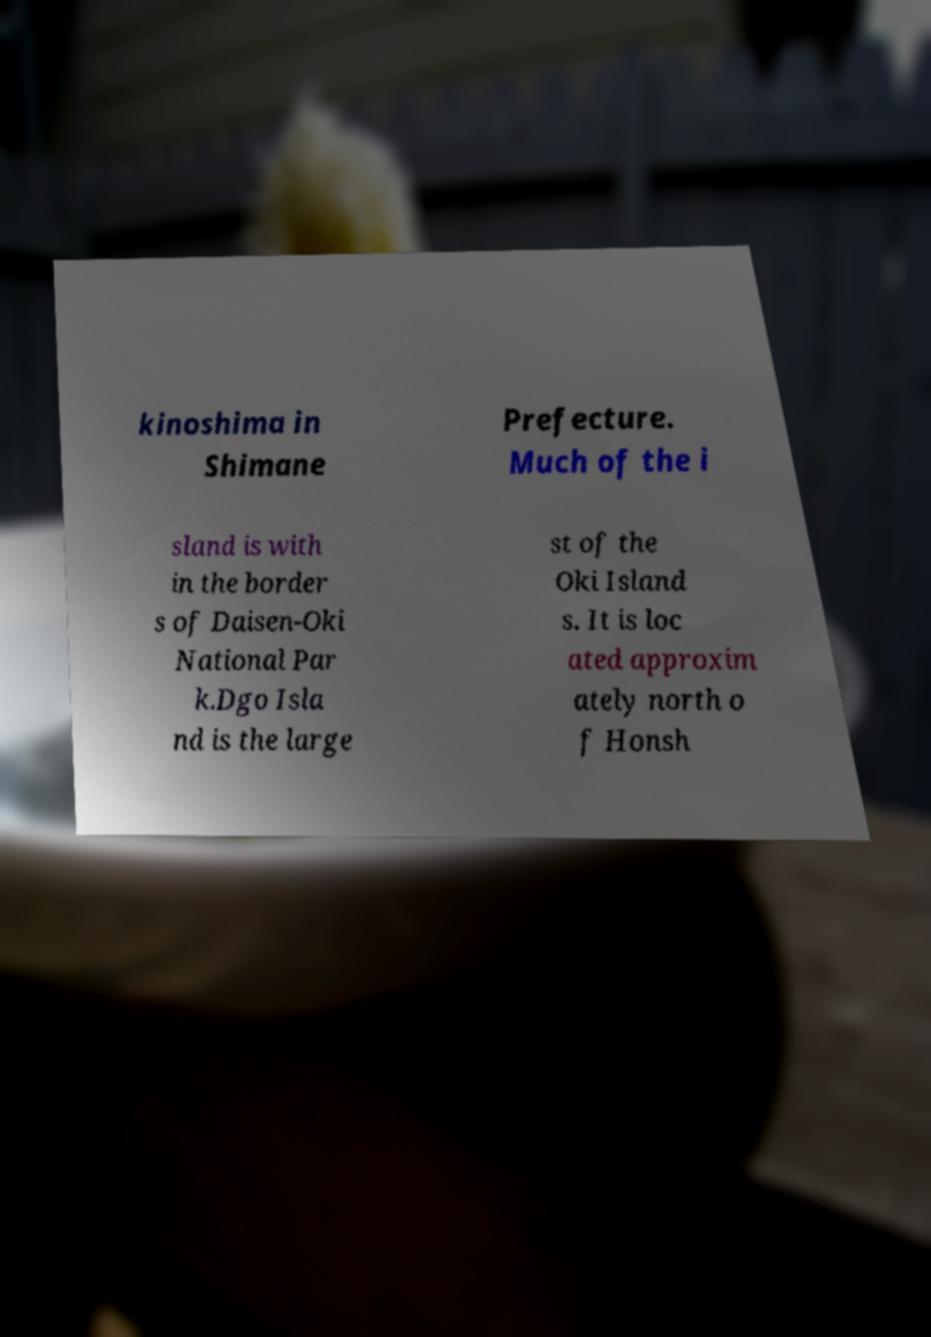For documentation purposes, I need the text within this image transcribed. Could you provide that? kinoshima in Shimane Prefecture. Much of the i sland is with in the border s of Daisen-Oki National Par k.Dgo Isla nd is the large st of the Oki Island s. It is loc ated approxim ately north o f Honsh 